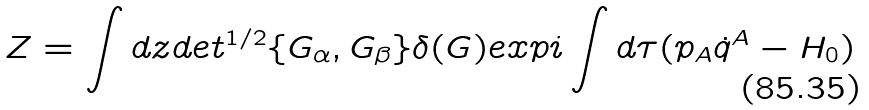Convert formula to latex. <formula><loc_0><loc_0><loc_500><loc_500>Z = \int d z d e t ^ { 1 / 2 } \{ G _ { \alpha } , G _ { \beta } \} \delta ( G ) e x p i \int d \tau ( p _ { A } \dot { q } ^ { A } - H _ { 0 } )</formula> 